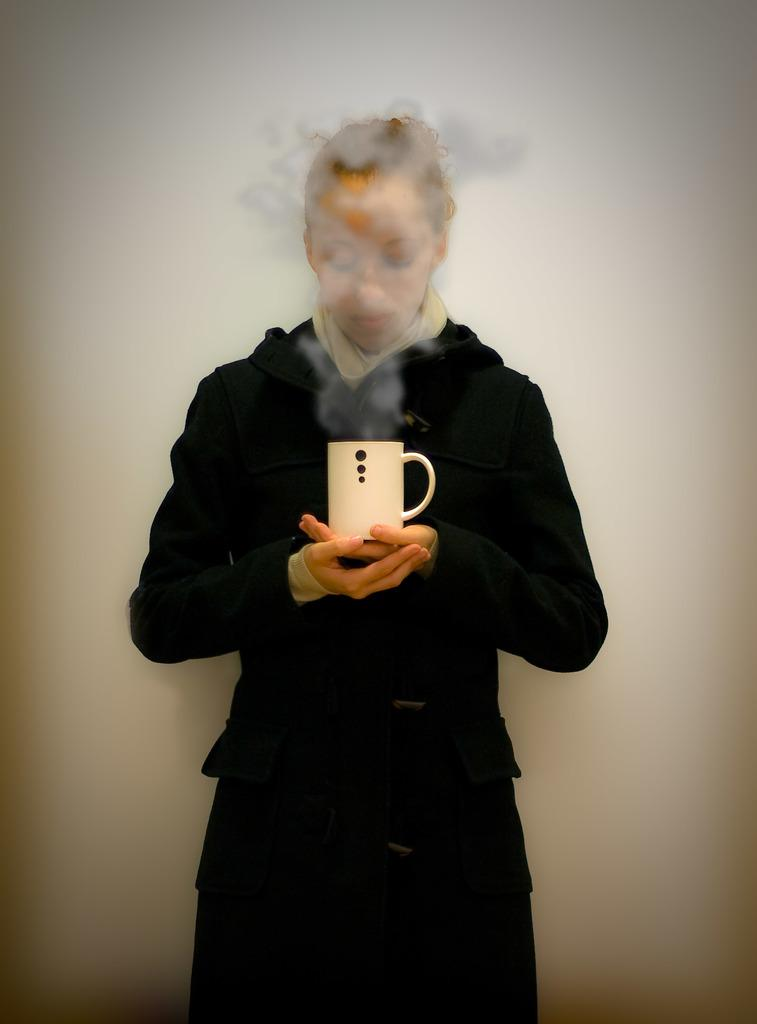Who is the main subject in the image? There is a woman in the image. What is the woman wearing? The woman is wearing a black dress. What object is the woman holding in the image? The woman is holding a cup. What is the color of the cup? The cup is white in color. What type of bean is the woman holding in the image? There is no bean present in the image; the woman is holding a white cup. Who is the manager of the woman in the image? There is no information about a manager or any other person in the image. 